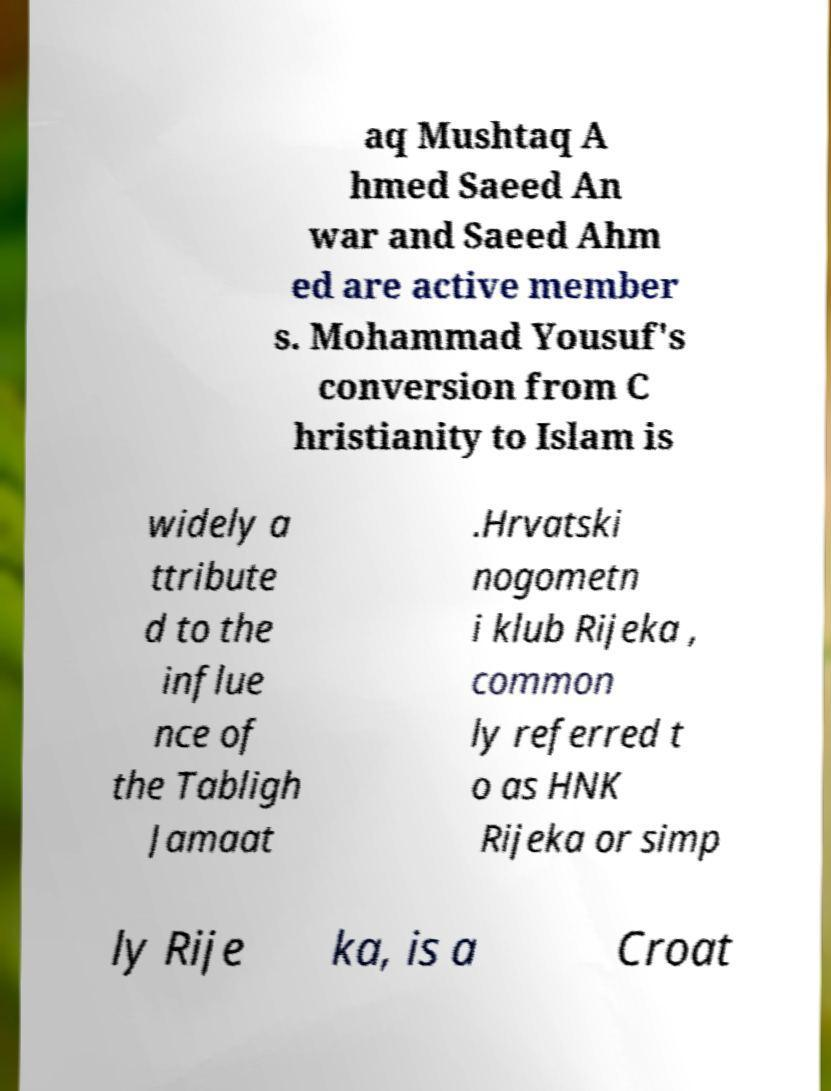Can you accurately transcribe the text from the provided image for me? aq Mushtaq A hmed Saeed An war and Saeed Ahm ed are active member s. Mohammad Yousuf's conversion from C hristianity to Islam is widely a ttribute d to the influe nce of the Tabligh Jamaat .Hrvatski nogometn i klub Rijeka , common ly referred t o as HNK Rijeka or simp ly Rije ka, is a Croat 